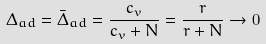<formula> <loc_0><loc_0><loc_500><loc_500>\Delta _ { a d } = \bar { \Delta } _ { a d } = \frac { c _ { v } } { c _ { v } + N } = \frac { r } { r + N } \rightarrow 0</formula> 